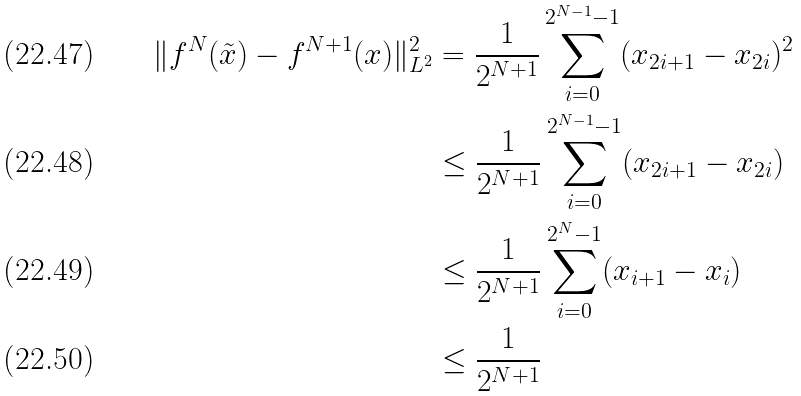<formula> <loc_0><loc_0><loc_500><loc_500>\| f ^ { N } ( \tilde { x } ) - f ^ { N + 1 } ( x ) \| _ { L ^ { 2 } } ^ { 2 } & = \frac { 1 } { 2 ^ { N + 1 } } \sum _ { i = 0 } ^ { 2 ^ { N - 1 } - 1 } ( x _ { 2 i + 1 } - x _ { 2 i } ) ^ { 2 } \\ & \leq \frac { 1 } { 2 ^ { N + 1 } } \sum _ { i = 0 } ^ { 2 ^ { N - 1 } - 1 } ( x _ { 2 i + 1 } - x _ { 2 i } ) \\ & \leq \frac { 1 } { 2 ^ { N + 1 } } \sum _ { i = 0 } ^ { 2 ^ { N } - 1 } ( x _ { i + 1 } - x _ { i } ) \\ & \leq \frac { 1 } { 2 ^ { N + 1 } }</formula> 